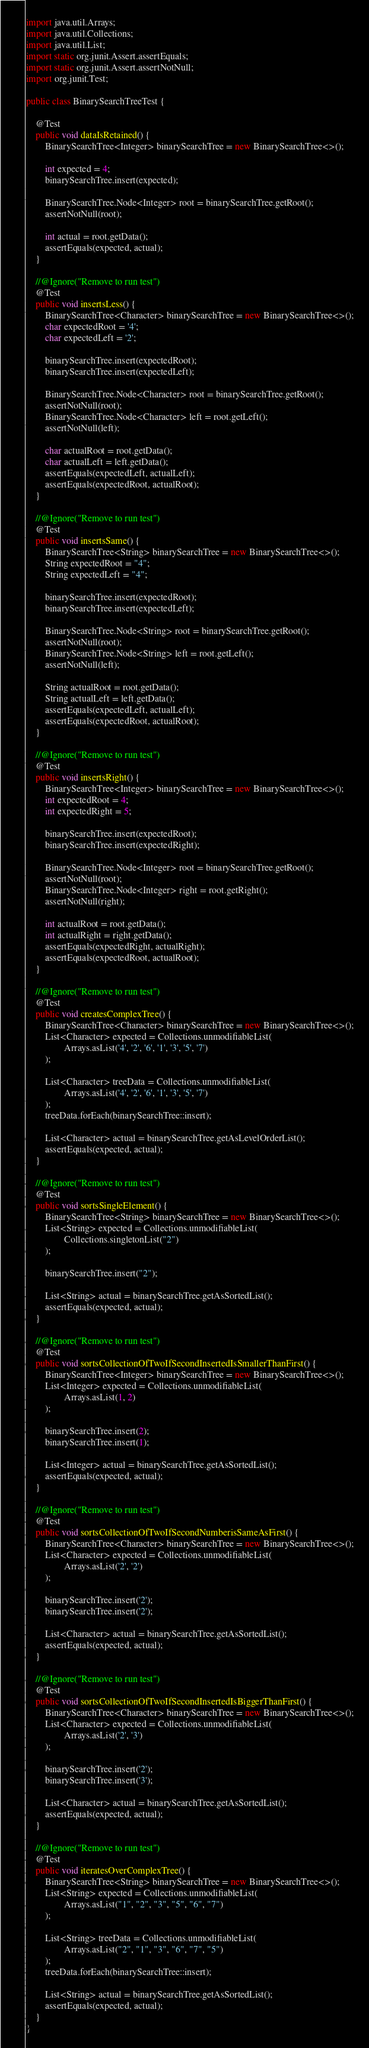Convert code to text. <code><loc_0><loc_0><loc_500><loc_500><_Java_>
import java.util.Arrays;
import java.util.Collections;
import java.util.List;
import static org.junit.Assert.assertEquals;
import static org.junit.Assert.assertNotNull;
import org.junit.Test;

public class BinarySearchTreeTest {

    @Test
    public void dataIsRetained() {
        BinarySearchTree<Integer> binarySearchTree = new BinarySearchTree<>();

        int expected = 4;
        binarySearchTree.insert(expected);

        BinarySearchTree.Node<Integer> root = binarySearchTree.getRoot();
        assertNotNull(root);

        int actual = root.getData();
        assertEquals(expected, actual);
    }

    //@Ignore("Remove to run test")
    @Test
    public void insertsLess() {
        BinarySearchTree<Character> binarySearchTree = new BinarySearchTree<>();
        char expectedRoot = '4';
        char expectedLeft = '2';

        binarySearchTree.insert(expectedRoot);
        binarySearchTree.insert(expectedLeft);

        BinarySearchTree.Node<Character> root = binarySearchTree.getRoot();
        assertNotNull(root);
        BinarySearchTree.Node<Character> left = root.getLeft();
        assertNotNull(left);

        char actualRoot = root.getData();
        char actualLeft = left.getData();
        assertEquals(expectedLeft, actualLeft);
        assertEquals(expectedRoot, actualRoot);
    }

    //@Ignore("Remove to run test")
    @Test
    public void insertsSame() {
        BinarySearchTree<String> binarySearchTree = new BinarySearchTree<>();
        String expectedRoot = "4";
        String expectedLeft = "4";

        binarySearchTree.insert(expectedRoot);
        binarySearchTree.insert(expectedLeft);

        BinarySearchTree.Node<String> root = binarySearchTree.getRoot();
        assertNotNull(root);
        BinarySearchTree.Node<String> left = root.getLeft();
        assertNotNull(left);

        String actualRoot = root.getData();
        String actualLeft = left.getData();
        assertEquals(expectedLeft, actualLeft);
        assertEquals(expectedRoot, actualRoot);
    }

    //@Ignore("Remove to run test")
    @Test
    public void insertsRight() {
        BinarySearchTree<Integer> binarySearchTree = new BinarySearchTree<>();
        int expectedRoot = 4;
        int expectedRight = 5;

        binarySearchTree.insert(expectedRoot);
        binarySearchTree.insert(expectedRight);

        BinarySearchTree.Node<Integer> root = binarySearchTree.getRoot();
        assertNotNull(root);
        BinarySearchTree.Node<Integer> right = root.getRight();
        assertNotNull(right);

        int actualRoot = root.getData();
        int actualRight = right.getData();
        assertEquals(expectedRight, actualRight);
        assertEquals(expectedRoot, actualRoot);
    }

    //@Ignore("Remove to run test")
    @Test
    public void createsComplexTree() {
        BinarySearchTree<Character> binarySearchTree = new BinarySearchTree<>();
        List<Character> expected = Collections.unmodifiableList(
                Arrays.asList('4', '2', '6', '1', '3', '5', '7')
        );

        List<Character> treeData = Collections.unmodifiableList(
                Arrays.asList('4', '2', '6', '1', '3', '5', '7')
        );
        treeData.forEach(binarySearchTree::insert);

        List<Character> actual = binarySearchTree.getAsLevelOrderList();
        assertEquals(expected, actual);
    }

    //@Ignore("Remove to run test")
    @Test
    public void sortsSingleElement() {
        BinarySearchTree<String> binarySearchTree = new BinarySearchTree<>();
        List<String> expected = Collections.unmodifiableList(
                Collections.singletonList("2")
        );

        binarySearchTree.insert("2");

        List<String> actual = binarySearchTree.getAsSortedList();
        assertEquals(expected, actual);
    }

    //@Ignore("Remove to run test")
    @Test
    public void sortsCollectionOfTwoIfSecondInsertedIsSmallerThanFirst() {
        BinarySearchTree<Integer> binarySearchTree = new BinarySearchTree<>();
        List<Integer> expected = Collections.unmodifiableList(
                Arrays.asList(1, 2)
        );

        binarySearchTree.insert(2);
        binarySearchTree.insert(1);

        List<Integer> actual = binarySearchTree.getAsSortedList();
        assertEquals(expected, actual);
    }

    //@Ignore("Remove to run test")
    @Test
    public void sortsCollectionOfTwoIfSecondNumberisSameAsFirst() {
        BinarySearchTree<Character> binarySearchTree = new BinarySearchTree<>();
        List<Character> expected = Collections.unmodifiableList(
                Arrays.asList('2', '2')
        );

        binarySearchTree.insert('2');
        binarySearchTree.insert('2');

        List<Character> actual = binarySearchTree.getAsSortedList();
        assertEquals(expected, actual);
    }

    //@Ignore("Remove to run test")
    @Test
    public void sortsCollectionOfTwoIfSecondInsertedIsBiggerThanFirst() {
        BinarySearchTree<Character> binarySearchTree = new BinarySearchTree<>();
        List<Character> expected = Collections.unmodifiableList(
                Arrays.asList('2', '3')
        );

        binarySearchTree.insert('2');
        binarySearchTree.insert('3');

        List<Character> actual = binarySearchTree.getAsSortedList();
        assertEquals(expected, actual);
    }

    //@Ignore("Remove to run test")
    @Test
    public void iteratesOverComplexTree() {
        BinarySearchTree<String> binarySearchTree = new BinarySearchTree<>();
        List<String> expected = Collections.unmodifiableList(
                Arrays.asList("1", "2", "3", "5", "6", "7")
        );

        List<String> treeData = Collections.unmodifiableList(
                Arrays.asList("2", "1", "3", "6", "7", "5")
        );
        treeData.forEach(binarySearchTree::insert);

        List<String> actual = binarySearchTree.getAsSortedList();
        assertEquals(expected, actual);
    }
}
</code> 